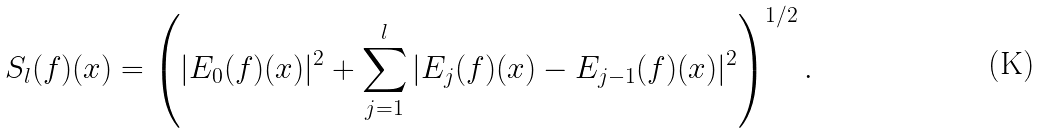Convert formula to latex. <formula><loc_0><loc_0><loc_500><loc_500>S _ { l } ( f ) ( x ) = \left ( | E _ { 0 } ( f ) ( x ) | ^ { 2 } + \sum _ { j = 1 } ^ { l } | E _ { j } ( f ) ( x ) - E _ { j - 1 } ( f ) ( x ) | ^ { 2 } \right ) ^ { 1 / 2 } .</formula> 